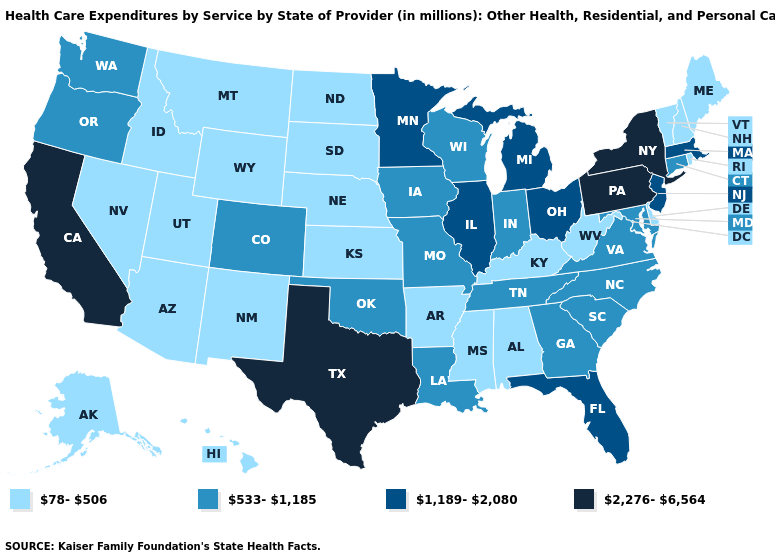What is the value of Maryland?
Answer briefly. 533-1,185. How many symbols are there in the legend?
Be succinct. 4. What is the lowest value in the USA?
Keep it brief. 78-506. Name the states that have a value in the range 533-1,185?
Give a very brief answer. Colorado, Connecticut, Georgia, Indiana, Iowa, Louisiana, Maryland, Missouri, North Carolina, Oklahoma, Oregon, South Carolina, Tennessee, Virginia, Washington, Wisconsin. Among the states that border Florida , does Georgia have the highest value?
Answer briefly. Yes. Does the first symbol in the legend represent the smallest category?
Concise answer only. Yes. Does Connecticut have the same value as Indiana?
Write a very short answer. Yes. What is the value of Washington?
Short answer required. 533-1,185. What is the lowest value in the USA?
Write a very short answer. 78-506. Does South Carolina have a lower value than Virginia?
Give a very brief answer. No. Which states have the highest value in the USA?
Quick response, please. California, New York, Pennsylvania, Texas. What is the value of Wyoming?
Give a very brief answer. 78-506. Does Indiana have the lowest value in the USA?
Write a very short answer. No. What is the value of Pennsylvania?
Concise answer only. 2,276-6,564. What is the value of Alabama?
Write a very short answer. 78-506. 